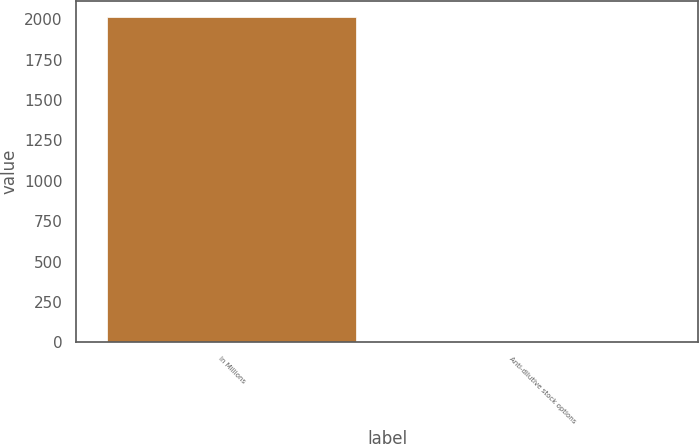Convert chart. <chart><loc_0><loc_0><loc_500><loc_500><bar_chart><fcel>In Millions<fcel>Anti-dilutive stock options<nl><fcel>2014<fcel>1.7<nl></chart> 